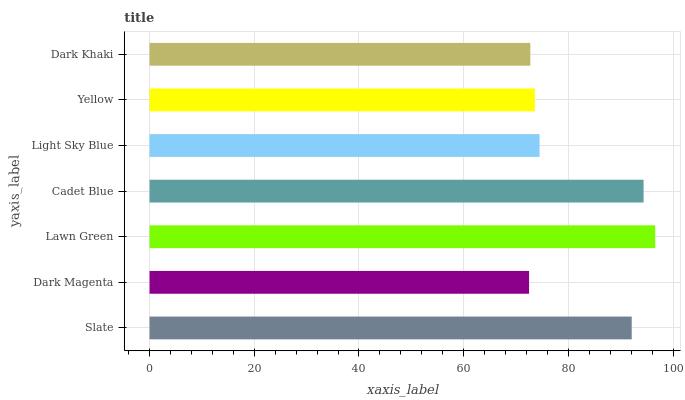Is Dark Magenta the minimum?
Answer yes or no. Yes. Is Lawn Green the maximum?
Answer yes or no. Yes. Is Lawn Green the minimum?
Answer yes or no. No. Is Dark Magenta the maximum?
Answer yes or no. No. Is Lawn Green greater than Dark Magenta?
Answer yes or no. Yes. Is Dark Magenta less than Lawn Green?
Answer yes or no. Yes. Is Dark Magenta greater than Lawn Green?
Answer yes or no. No. Is Lawn Green less than Dark Magenta?
Answer yes or no. No. Is Light Sky Blue the high median?
Answer yes or no. Yes. Is Light Sky Blue the low median?
Answer yes or no. Yes. Is Dark Magenta the high median?
Answer yes or no. No. Is Cadet Blue the low median?
Answer yes or no. No. 